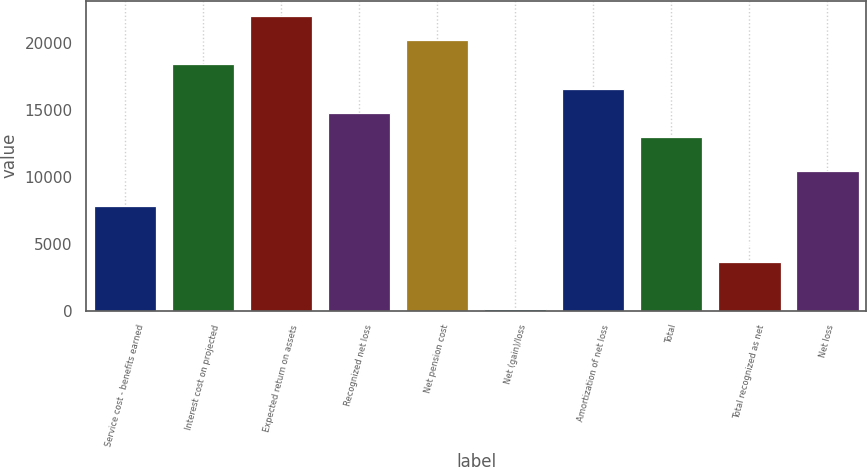Convert chart. <chart><loc_0><loc_0><loc_500><loc_500><bar_chart><fcel>Service cost - benefits earned<fcel>Interest cost on projected<fcel>Expected return on assets<fcel>Recognized net loss<fcel>Net pension cost<fcel>Net (gain)/loss<fcel>Amortization of net loss<fcel>Total<fcel>Total recognized as net<fcel>Net loss<nl><fcel>7827<fcel>18405<fcel>22039<fcel>14771<fcel>20222<fcel>101<fcel>16588<fcel>12954<fcel>3627<fcel>10414<nl></chart> 